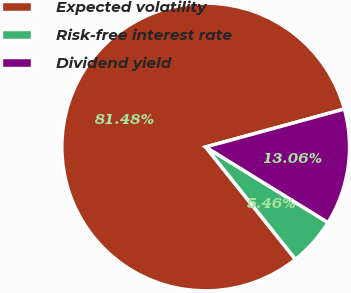Convert chart. <chart><loc_0><loc_0><loc_500><loc_500><pie_chart><fcel>Expected volatility<fcel>Risk-free interest rate<fcel>Dividend yield<nl><fcel>81.47%<fcel>5.46%<fcel>13.06%<nl></chart> 